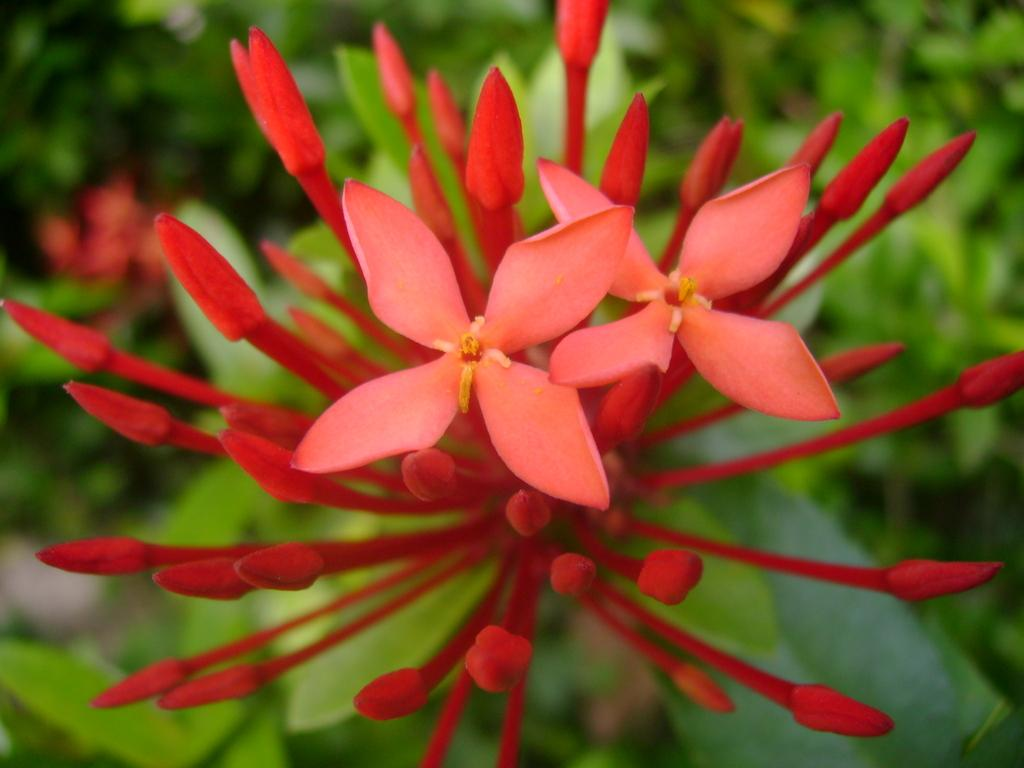What is present in the picture? There is a plant in the picture. What stage of growth are the plant's buds in? The plant has buds. What additional features can be seen on the plant? The plant has flowers. How would you describe the background of the image? The background of the image is blurred. Where are the friends sitting on the station in the image? There are no friends or stations present in the image; it features a plant with buds and flowers against a blurred background. 